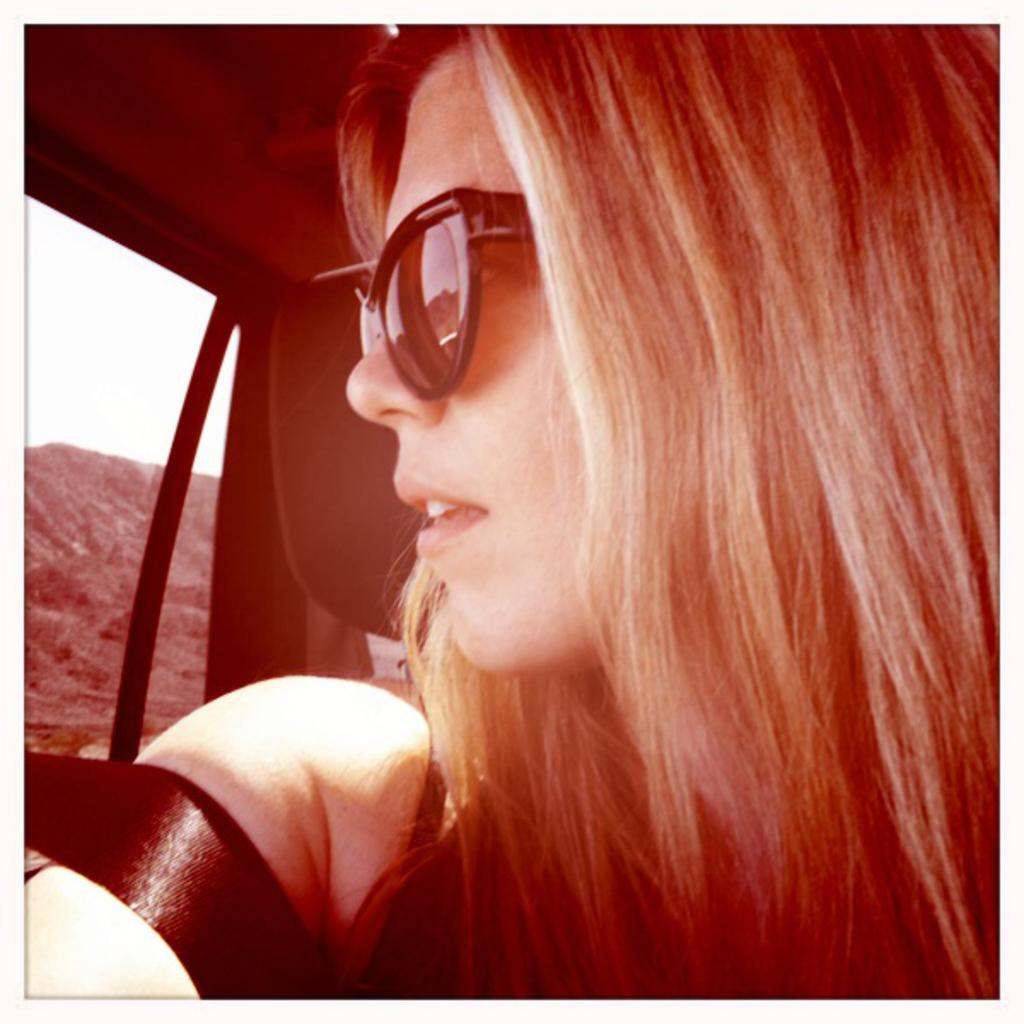What is the perspective of the image? The image is taken from inside a car. Who or what can be seen on the right side of the image? There is a woman on the right side of the image. What is visible on the left side of the image? There is a window glass on the left side of the image. How many oranges are present in the image? There are no oranges visible in the image. 